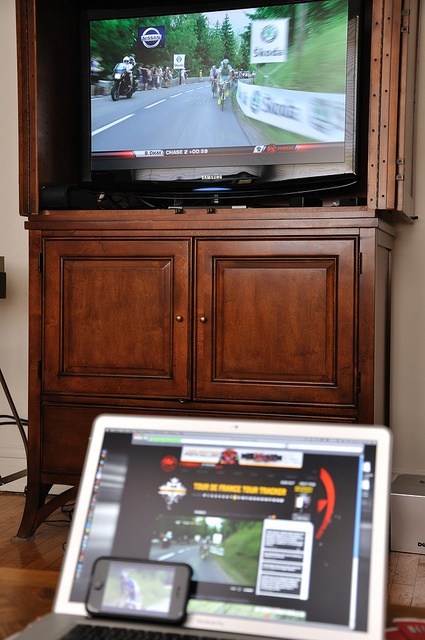Describe the objects in this image and their specific colors. I can see laptop in darkgray, white, gray, and black tones, tv in darkgray, black, lightblue, and gray tones, cell phone in darkgray, lightgray, and gray tones, keyboard in darkgray, black, and gray tones, and people in darkgray, gray, and black tones in this image. 